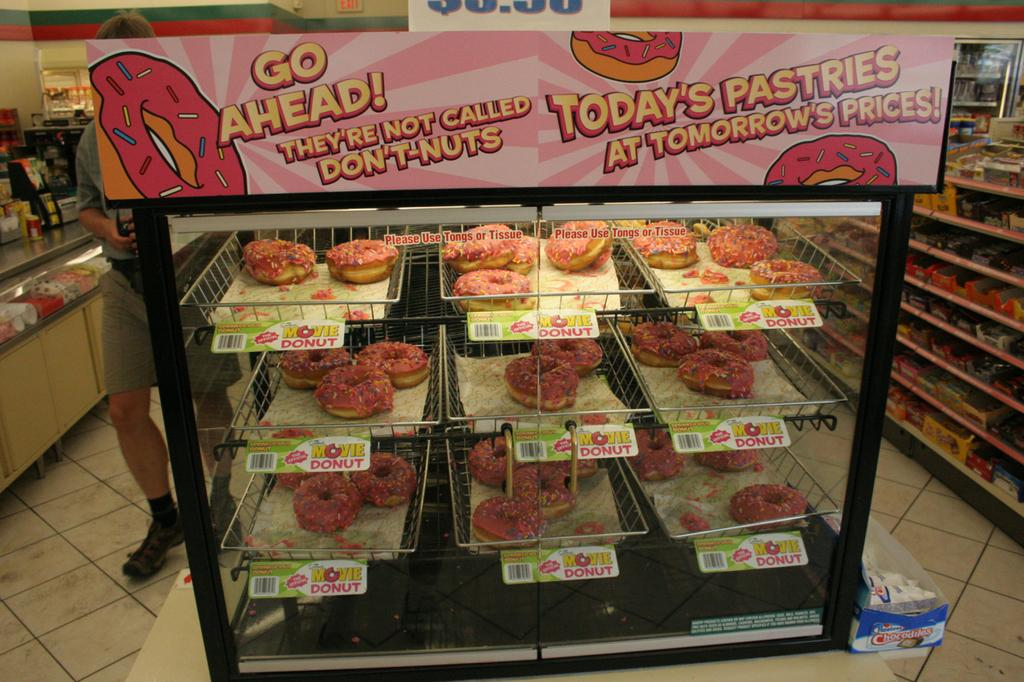<image>
Give a short and clear explanation of the subsequent image. Display of sprinkle donuts or as the sign says Movie Donut 